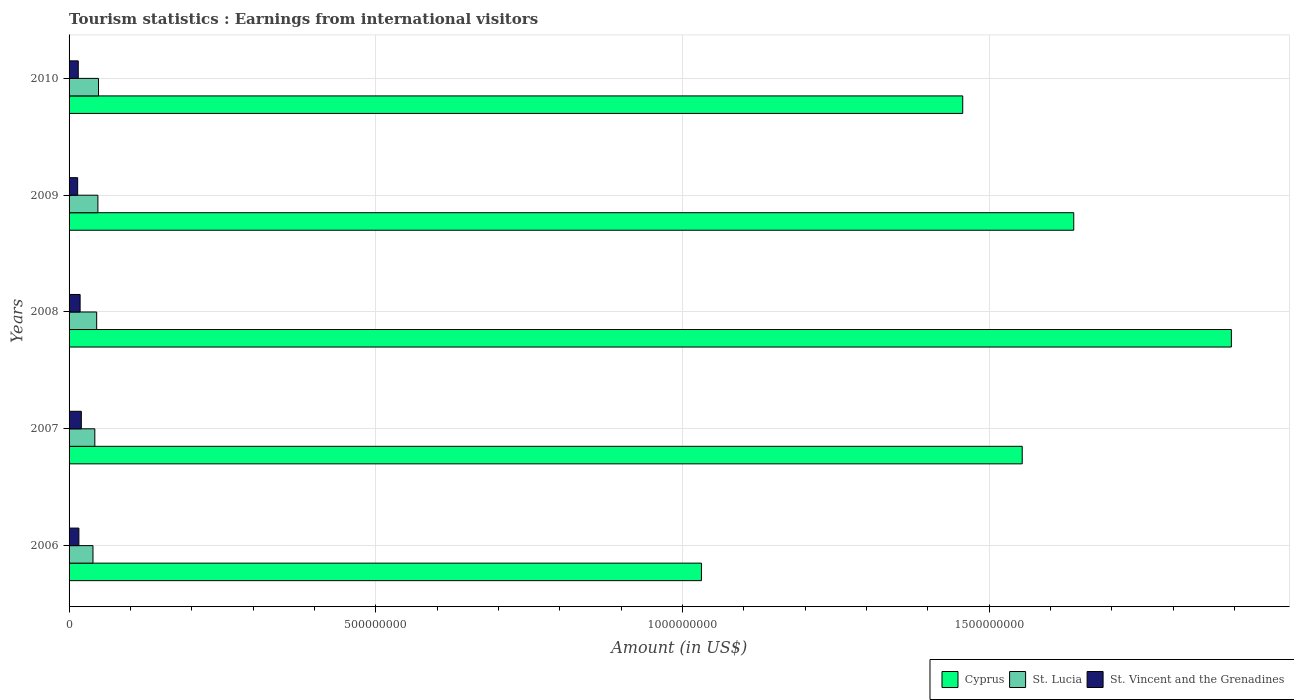Are the number of bars per tick equal to the number of legend labels?
Give a very brief answer. Yes. Are the number of bars on each tick of the Y-axis equal?
Your answer should be very brief. Yes. How many bars are there on the 3rd tick from the top?
Provide a short and direct response. 3. In how many cases, is the number of bars for a given year not equal to the number of legend labels?
Provide a succinct answer. 0. What is the earnings from international visitors in St. Lucia in 2006?
Your answer should be very brief. 3.90e+07. Across all years, what is the maximum earnings from international visitors in St. Lucia?
Provide a short and direct response. 4.80e+07. Across all years, what is the minimum earnings from international visitors in St. Lucia?
Make the answer very short. 3.90e+07. In which year was the earnings from international visitors in St. Lucia maximum?
Make the answer very short. 2010. What is the total earnings from international visitors in St. Vincent and the Grenadines in the graph?
Give a very brief answer. 8.30e+07. What is the difference between the earnings from international visitors in St. Vincent and the Grenadines in 2006 and that in 2009?
Provide a succinct answer. 2.00e+06. What is the difference between the earnings from international visitors in St. Lucia in 2006 and the earnings from international visitors in St. Vincent and the Grenadines in 2007?
Keep it short and to the point. 1.90e+07. What is the average earnings from international visitors in Cyprus per year?
Your response must be concise. 1.52e+09. In the year 2007, what is the difference between the earnings from international visitors in St. Lucia and earnings from international visitors in Cyprus?
Your answer should be compact. -1.51e+09. In how many years, is the earnings from international visitors in Cyprus greater than 1000000000 US$?
Keep it short and to the point. 5. What is the ratio of the earnings from international visitors in St. Lucia in 2008 to that in 2009?
Your answer should be very brief. 0.96. Is the difference between the earnings from international visitors in St. Lucia in 2006 and 2008 greater than the difference between the earnings from international visitors in Cyprus in 2006 and 2008?
Offer a terse response. Yes. What is the difference between the highest and the lowest earnings from international visitors in St. Lucia?
Your response must be concise. 9.00e+06. In how many years, is the earnings from international visitors in St. Lucia greater than the average earnings from international visitors in St. Lucia taken over all years?
Your response must be concise. 3. Is the sum of the earnings from international visitors in St. Lucia in 2007 and 2010 greater than the maximum earnings from international visitors in Cyprus across all years?
Your response must be concise. No. What does the 2nd bar from the top in 2009 represents?
Your answer should be compact. St. Lucia. What does the 1st bar from the bottom in 2006 represents?
Your response must be concise. Cyprus. How many bars are there?
Provide a succinct answer. 15. Are all the bars in the graph horizontal?
Offer a terse response. Yes. How many years are there in the graph?
Keep it short and to the point. 5. What is the difference between two consecutive major ticks on the X-axis?
Your answer should be compact. 5.00e+08. Are the values on the major ticks of X-axis written in scientific E-notation?
Provide a succinct answer. No. Does the graph contain grids?
Your response must be concise. Yes. Where does the legend appear in the graph?
Your answer should be very brief. Bottom right. How are the legend labels stacked?
Offer a very short reply. Horizontal. What is the title of the graph?
Keep it short and to the point. Tourism statistics : Earnings from international visitors. What is the label or title of the X-axis?
Offer a terse response. Amount (in US$). What is the label or title of the Y-axis?
Offer a terse response. Years. What is the Amount (in US$) in Cyprus in 2006?
Provide a succinct answer. 1.03e+09. What is the Amount (in US$) of St. Lucia in 2006?
Offer a very short reply. 3.90e+07. What is the Amount (in US$) in St. Vincent and the Grenadines in 2006?
Give a very brief answer. 1.60e+07. What is the Amount (in US$) of Cyprus in 2007?
Provide a short and direct response. 1.55e+09. What is the Amount (in US$) of St. Lucia in 2007?
Your answer should be compact. 4.20e+07. What is the Amount (in US$) of Cyprus in 2008?
Keep it short and to the point. 1.90e+09. What is the Amount (in US$) of St. Lucia in 2008?
Provide a succinct answer. 4.50e+07. What is the Amount (in US$) in St. Vincent and the Grenadines in 2008?
Provide a short and direct response. 1.80e+07. What is the Amount (in US$) in Cyprus in 2009?
Your answer should be compact. 1.64e+09. What is the Amount (in US$) of St. Lucia in 2009?
Provide a short and direct response. 4.70e+07. What is the Amount (in US$) of St. Vincent and the Grenadines in 2009?
Offer a very short reply. 1.40e+07. What is the Amount (in US$) in Cyprus in 2010?
Give a very brief answer. 1.46e+09. What is the Amount (in US$) in St. Lucia in 2010?
Provide a succinct answer. 4.80e+07. What is the Amount (in US$) of St. Vincent and the Grenadines in 2010?
Make the answer very short. 1.50e+07. Across all years, what is the maximum Amount (in US$) in Cyprus?
Offer a terse response. 1.90e+09. Across all years, what is the maximum Amount (in US$) of St. Lucia?
Your response must be concise. 4.80e+07. Across all years, what is the minimum Amount (in US$) of Cyprus?
Make the answer very short. 1.03e+09. Across all years, what is the minimum Amount (in US$) of St. Lucia?
Offer a terse response. 3.90e+07. Across all years, what is the minimum Amount (in US$) in St. Vincent and the Grenadines?
Offer a terse response. 1.40e+07. What is the total Amount (in US$) of Cyprus in the graph?
Give a very brief answer. 7.58e+09. What is the total Amount (in US$) of St. Lucia in the graph?
Your answer should be compact. 2.21e+08. What is the total Amount (in US$) in St. Vincent and the Grenadines in the graph?
Provide a short and direct response. 8.30e+07. What is the difference between the Amount (in US$) in Cyprus in 2006 and that in 2007?
Keep it short and to the point. -5.23e+08. What is the difference between the Amount (in US$) in Cyprus in 2006 and that in 2008?
Your answer should be compact. -8.64e+08. What is the difference between the Amount (in US$) of St. Lucia in 2006 and that in 2008?
Give a very brief answer. -6.00e+06. What is the difference between the Amount (in US$) in St. Vincent and the Grenadines in 2006 and that in 2008?
Your answer should be very brief. -2.00e+06. What is the difference between the Amount (in US$) in Cyprus in 2006 and that in 2009?
Your answer should be compact. -6.07e+08. What is the difference between the Amount (in US$) of St. Lucia in 2006 and that in 2009?
Offer a terse response. -8.00e+06. What is the difference between the Amount (in US$) of Cyprus in 2006 and that in 2010?
Give a very brief answer. -4.26e+08. What is the difference between the Amount (in US$) of St. Lucia in 2006 and that in 2010?
Give a very brief answer. -9.00e+06. What is the difference between the Amount (in US$) of St. Vincent and the Grenadines in 2006 and that in 2010?
Keep it short and to the point. 1.00e+06. What is the difference between the Amount (in US$) of Cyprus in 2007 and that in 2008?
Your answer should be compact. -3.41e+08. What is the difference between the Amount (in US$) of St. Lucia in 2007 and that in 2008?
Give a very brief answer. -3.00e+06. What is the difference between the Amount (in US$) in St. Vincent and the Grenadines in 2007 and that in 2008?
Offer a terse response. 2.00e+06. What is the difference between the Amount (in US$) in Cyprus in 2007 and that in 2009?
Your response must be concise. -8.40e+07. What is the difference between the Amount (in US$) of St. Lucia in 2007 and that in 2009?
Keep it short and to the point. -5.00e+06. What is the difference between the Amount (in US$) in St. Vincent and the Grenadines in 2007 and that in 2009?
Your response must be concise. 6.00e+06. What is the difference between the Amount (in US$) in Cyprus in 2007 and that in 2010?
Your answer should be compact. 9.70e+07. What is the difference between the Amount (in US$) in St. Lucia in 2007 and that in 2010?
Your response must be concise. -6.00e+06. What is the difference between the Amount (in US$) of Cyprus in 2008 and that in 2009?
Your answer should be very brief. 2.57e+08. What is the difference between the Amount (in US$) of Cyprus in 2008 and that in 2010?
Your answer should be very brief. 4.38e+08. What is the difference between the Amount (in US$) of St. Lucia in 2008 and that in 2010?
Offer a very short reply. -3.00e+06. What is the difference between the Amount (in US$) of St. Vincent and the Grenadines in 2008 and that in 2010?
Make the answer very short. 3.00e+06. What is the difference between the Amount (in US$) in Cyprus in 2009 and that in 2010?
Your response must be concise. 1.81e+08. What is the difference between the Amount (in US$) in St. Vincent and the Grenadines in 2009 and that in 2010?
Provide a short and direct response. -1.00e+06. What is the difference between the Amount (in US$) in Cyprus in 2006 and the Amount (in US$) in St. Lucia in 2007?
Give a very brief answer. 9.89e+08. What is the difference between the Amount (in US$) of Cyprus in 2006 and the Amount (in US$) of St. Vincent and the Grenadines in 2007?
Provide a short and direct response. 1.01e+09. What is the difference between the Amount (in US$) in St. Lucia in 2006 and the Amount (in US$) in St. Vincent and the Grenadines in 2007?
Provide a succinct answer. 1.90e+07. What is the difference between the Amount (in US$) in Cyprus in 2006 and the Amount (in US$) in St. Lucia in 2008?
Offer a very short reply. 9.86e+08. What is the difference between the Amount (in US$) in Cyprus in 2006 and the Amount (in US$) in St. Vincent and the Grenadines in 2008?
Offer a very short reply. 1.01e+09. What is the difference between the Amount (in US$) in St. Lucia in 2006 and the Amount (in US$) in St. Vincent and the Grenadines in 2008?
Keep it short and to the point. 2.10e+07. What is the difference between the Amount (in US$) of Cyprus in 2006 and the Amount (in US$) of St. Lucia in 2009?
Give a very brief answer. 9.84e+08. What is the difference between the Amount (in US$) of Cyprus in 2006 and the Amount (in US$) of St. Vincent and the Grenadines in 2009?
Make the answer very short. 1.02e+09. What is the difference between the Amount (in US$) in St. Lucia in 2006 and the Amount (in US$) in St. Vincent and the Grenadines in 2009?
Your answer should be compact. 2.50e+07. What is the difference between the Amount (in US$) in Cyprus in 2006 and the Amount (in US$) in St. Lucia in 2010?
Offer a terse response. 9.83e+08. What is the difference between the Amount (in US$) in Cyprus in 2006 and the Amount (in US$) in St. Vincent and the Grenadines in 2010?
Give a very brief answer. 1.02e+09. What is the difference between the Amount (in US$) of St. Lucia in 2006 and the Amount (in US$) of St. Vincent and the Grenadines in 2010?
Your response must be concise. 2.40e+07. What is the difference between the Amount (in US$) of Cyprus in 2007 and the Amount (in US$) of St. Lucia in 2008?
Ensure brevity in your answer.  1.51e+09. What is the difference between the Amount (in US$) in Cyprus in 2007 and the Amount (in US$) in St. Vincent and the Grenadines in 2008?
Make the answer very short. 1.54e+09. What is the difference between the Amount (in US$) in St. Lucia in 2007 and the Amount (in US$) in St. Vincent and the Grenadines in 2008?
Make the answer very short. 2.40e+07. What is the difference between the Amount (in US$) of Cyprus in 2007 and the Amount (in US$) of St. Lucia in 2009?
Your response must be concise. 1.51e+09. What is the difference between the Amount (in US$) in Cyprus in 2007 and the Amount (in US$) in St. Vincent and the Grenadines in 2009?
Give a very brief answer. 1.54e+09. What is the difference between the Amount (in US$) of St. Lucia in 2007 and the Amount (in US$) of St. Vincent and the Grenadines in 2009?
Provide a short and direct response. 2.80e+07. What is the difference between the Amount (in US$) in Cyprus in 2007 and the Amount (in US$) in St. Lucia in 2010?
Offer a very short reply. 1.51e+09. What is the difference between the Amount (in US$) of Cyprus in 2007 and the Amount (in US$) of St. Vincent and the Grenadines in 2010?
Your answer should be compact. 1.54e+09. What is the difference between the Amount (in US$) of St. Lucia in 2007 and the Amount (in US$) of St. Vincent and the Grenadines in 2010?
Your response must be concise. 2.70e+07. What is the difference between the Amount (in US$) of Cyprus in 2008 and the Amount (in US$) of St. Lucia in 2009?
Ensure brevity in your answer.  1.85e+09. What is the difference between the Amount (in US$) of Cyprus in 2008 and the Amount (in US$) of St. Vincent and the Grenadines in 2009?
Give a very brief answer. 1.88e+09. What is the difference between the Amount (in US$) in St. Lucia in 2008 and the Amount (in US$) in St. Vincent and the Grenadines in 2009?
Offer a terse response. 3.10e+07. What is the difference between the Amount (in US$) in Cyprus in 2008 and the Amount (in US$) in St. Lucia in 2010?
Your response must be concise. 1.85e+09. What is the difference between the Amount (in US$) of Cyprus in 2008 and the Amount (in US$) of St. Vincent and the Grenadines in 2010?
Your response must be concise. 1.88e+09. What is the difference between the Amount (in US$) of St. Lucia in 2008 and the Amount (in US$) of St. Vincent and the Grenadines in 2010?
Offer a terse response. 3.00e+07. What is the difference between the Amount (in US$) in Cyprus in 2009 and the Amount (in US$) in St. Lucia in 2010?
Give a very brief answer. 1.59e+09. What is the difference between the Amount (in US$) in Cyprus in 2009 and the Amount (in US$) in St. Vincent and the Grenadines in 2010?
Ensure brevity in your answer.  1.62e+09. What is the difference between the Amount (in US$) of St. Lucia in 2009 and the Amount (in US$) of St. Vincent and the Grenadines in 2010?
Your answer should be very brief. 3.20e+07. What is the average Amount (in US$) in Cyprus per year?
Your response must be concise. 1.52e+09. What is the average Amount (in US$) of St. Lucia per year?
Ensure brevity in your answer.  4.42e+07. What is the average Amount (in US$) in St. Vincent and the Grenadines per year?
Ensure brevity in your answer.  1.66e+07. In the year 2006, what is the difference between the Amount (in US$) of Cyprus and Amount (in US$) of St. Lucia?
Make the answer very short. 9.92e+08. In the year 2006, what is the difference between the Amount (in US$) of Cyprus and Amount (in US$) of St. Vincent and the Grenadines?
Provide a short and direct response. 1.02e+09. In the year 2006, what is the difference between the Amount (in US$) of St. Lucia and Amount (in US$) of St. Vincent and the Grenadines?
Your response must be concise. 2.30e+07. In the year 2007, what is the difference between the Amount (in US$) in Cyprus and Amount (in US$) in St. Lucia?
Make the answer very short. 1.51e+09. In the year 2007, what is the difference between the Amount (in US$) in Cyprus and Amount (in US$) in St. Vincent and the Grenadines?
Your answer should be very brief. 1.53e+09. In the year 2007, what is the difference between the Amount (in US$) in St. Lucia and Amount (in US$) in St. Vincent and the Grenadines?
Provide a short and direct response. 2.20e+07. In the year 2008, what is the difference between the Amount (in US$) of Cyprus and Amount (in US$) of St. Lucia?
Make the answer very short. 1.85e+09. In the year 2008, what is the difference between the Amount (in US$) of Cyprus and Amount (in US$) of St. Vincent and the Grenadines?
Provide a succinct answer. 1.88e+09. In the year 2008, what is the difference between the Amount (in US$) of St. Lucia and Amount (in US$) of St. Vincent and the Grenadines?
Your answer should be very brief. 2.70e+07. In the year 2009, what is the difference between the Amount (in US$) of Cyprus and Amount (in US$) of St. Lucia?
Keep it short and to the point. 1.59e+09. In the year 2009, what is the difference between the Amount (in US$) of Cyprus and Amount (in US$) of St. Vincent and the Grenadines?
Your response must be concise. 1.62e+09. In the year 2009, what is the difference between the Amount (in US$) of St. Lucia and Amount (in US$) of St. Vincent and the Grenadines?
Give a very brief answer. 3.30e+07. In the year 2010, what is the difference between the Amount (in US$) of Cyprus and Amount (in US$) of St. Lucia?
Provide a succinct answer. 1.41e+09. In the year 2010, what is the difference between the Amount (in US$) of Cyprus and Amount (in US$) of St. Vincent and the Grenadines?
Keep it short and to the point. 1.44e+09. In the year 2010, what is the difference between the Amount (in US$) in St. Lucia and Amount (in US$) in St. Vincent and the Grenadines?
Provide a succinct answer. 3.30e+07. What is the ratio of the Amount (in US$) of Cyprus in 2006 to that in 2007?
Your response must be concise. 0.66. What is the ratio of the Amount (in US$) of St. Vincent and the Grenadines in 2006 to that in 2007?
Your response must be concise. 0.8. What is the ratio of the Amount (in US$) of Cyprus in 2006 to that in 2008?
Offer a terse response. 0.54. What is the ratio of the Amount (in US$) of St. Lucia in 2006 to that in 2008?
Offer a very short reply. 0.87. What is the ratio of the Amount (in US$) in Cyprus in 2006 to that in 2009?
Your answer should be very brief. 0.63. What is the ratio of the Amount (in US$) of St. Lucia in 2006 to that in 2009?
Keep it short and to the point. 0.83. What is the ratio of the Amount (in US$) of Cyprus in 2006 to that in 2010?
Your answer should be very brief. 0.71. What is the ratio of the Amount (in US$) of St. Lucia in 2006 to that in 2010?
Your answer should be very brief. 0.81. What is the ratio of the Amount (in US$) in St. Vincent and the Grenadines in 2006 to that in 2010?
Give a very brief answer. 1.07. What is the ratio of the Amount (in US$) of Cyprus in 2007 to that in 2008?
Give a very brief answer. 0.82. What is the ratio of the Amount (in US$) of St. Vincent and the Grenadines in 2007 to that in 2008?
Your answer should be compact. 1.11. What is the ratio of the Amount (in US$) in Cyprus in 2007 to that in 2009?
Your answer should be compact. 0.95. What is the ratio of the Amount (in US$) in St. Lucia in 2007 to that in 2009?
Offer a terse response. 0.89. What is the ratio of the Amount (in US$) in St. Vincent and the Grenadines in 2007 to that in 2009?
Ensure brevity in your answer.  1.43. What is the ratio of the Amount (in US$) of Cyprus in 2007 to that in 2010?
Provide a succinct answer. 1.07. What is the ratio of the Amount (in US$) of St. Lucia in 2007 to that in 2010?
Ensure brevity in your answer.  0.88. What is the ratio of the Amount (in US$) of St. Vincent and the Grenadines in 2007 to that in 2010?
Your response must be concise. 1.33. What is the ratio of the Amount (in US$) of Cyprus in 2008 to that in 2009?
Provide a short and direct response. 1.16. What is the ratio of the Amount (in US$) in St. Lucia in 2008 to that in 2009?
Give a very brief answer. 0.96. What is the ratio of the Amount (in US$) in St. Vincent and the Grenadines in 2008 to that in 2009?
Ensure brevity in your answer.  1.29. What is the ratio of the Amount (in US$) of Cyprus in 2008 to that in 2010?
Keep it short and to the point. 1.3. What is the ratio of the Amount (in US$) of St. Lucia in 2008 to that in 2010?
Keep it short and to the point. 0.94. What is the ratio of the Amount (in US$) in Cyprus in 2009 to that in 2010?
Your response must be concise. 1.12. What is the ratio of the Amount (in US$) of St. Lucia in 2009 to that in 2010?
Your answer should be compact. 0.98. What is the ratio of the Amount (in US$) of St. Vincent and the Grenadines in 2009 to that in 2010?
Provide a short and direct response. 0.93. What is the difference between the highest and the second highest Amount (in US$) of Cyprus?
Your answer should be compact. 2.57e+08. What is the difference between the highest and the second highest Amount (in US$) in St. Lucia?
Keep it short and to the point. 1.00e+06. What is the difference between the highest and the second highest Amount (in US$) of St. Vincent and the Grenadines?
Provide a succinct answer. 2.00e+06. What is the difference between the highest and the lowest Amount (in US$) of Cyprus?
Offer a very short reply. 8.64e+08. What is the difference between the highest and the lowest Amount (in US$) of St. Lucia?
Ensure brevity in your answer.  9.00e+06. 